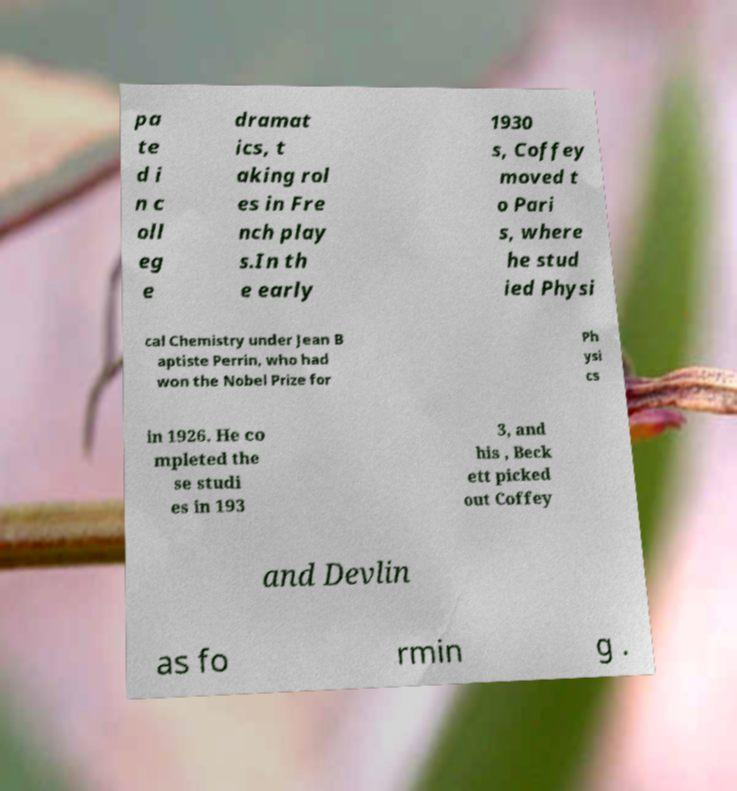There's text embedded in this image that I need extracted. Can you transcribe it verbatim? pa te d i n c oll eg e dramat ics, t aking rol es in Fre nch play s.In th e early 1930 s, Coffey moved t o Pari s, where he stud ied Physi cal Chemistry under Jean B aptiste Perrin, who had won the Nobel Prize for Ph ysi cs in 1926. He co mpleted the se studi es in 193 3, and his , Beck ett picked out Coffey and Devlin as fo rmin g . 